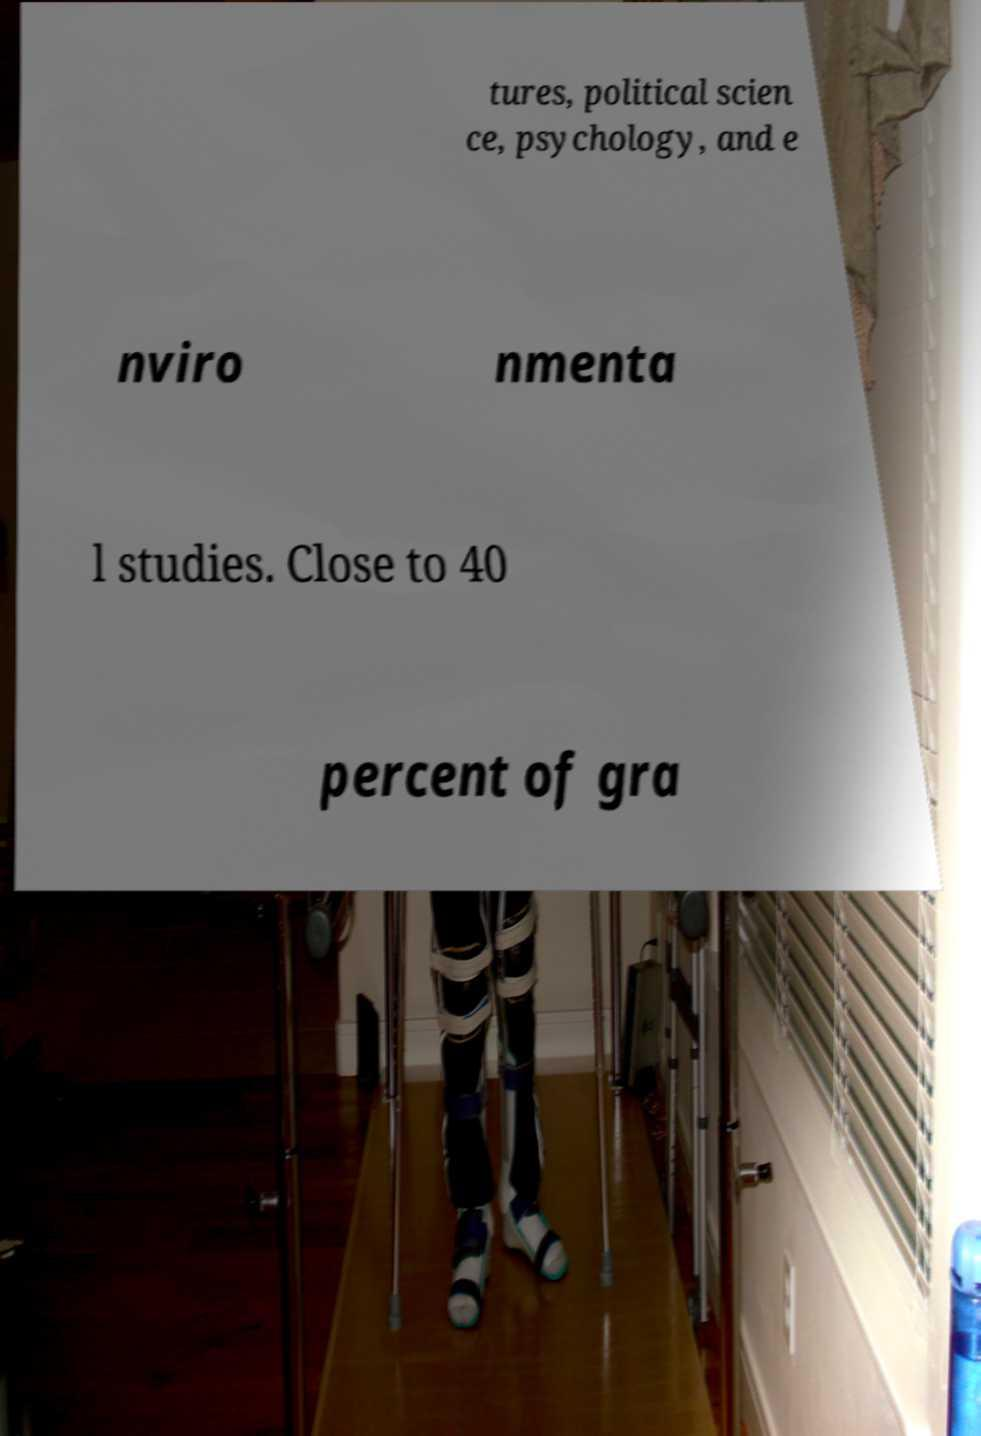For documentation purposes, I need the text within this image transcribed. Could you provide that? tures, political scien ce, psychology, and e nviro nmenta l studies. Close to 40 percent of gra 